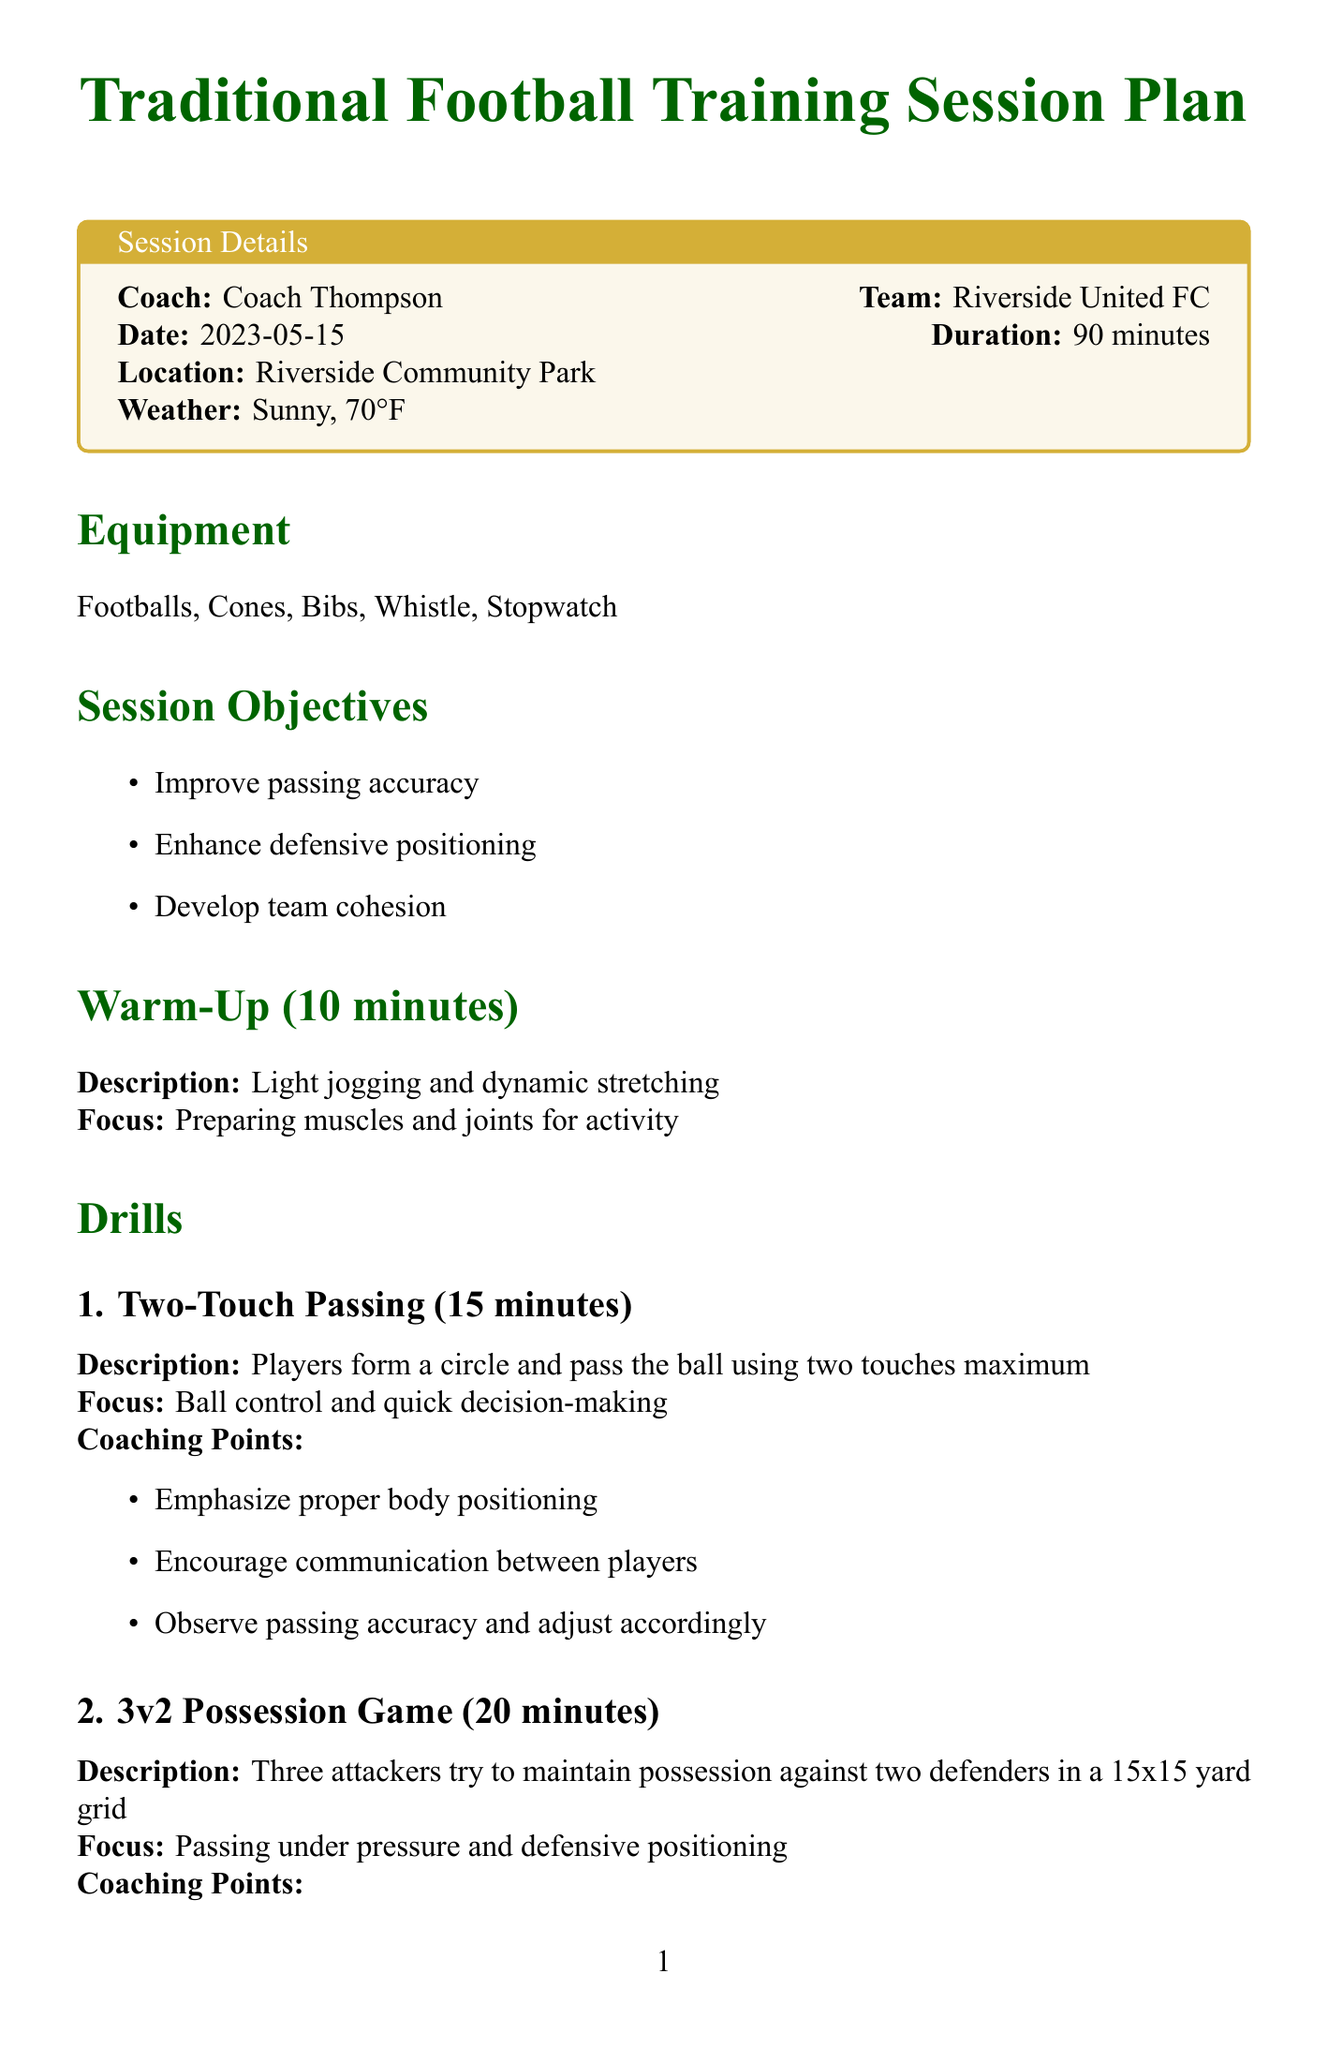what is the coach's name? The coach's name is specified clearly in the document within the session details box.
Answer: Coach Thompson what is the duration of the training session? The duration is listed explicitly in the session details section of the document.
Answer: 90 minutes what is the primary focus during the warm-up? The warm-up section of the document highlights the focus of this activity before the drills begin.
Answer: Preparing muscles and joints for activity how long does the Full-Field Scrimmage last? The duration of the Full-Field Scrimmage drill is provided under the drills section.
Answer: 30 minutes what are the session objectives? The session objectives are specified in a bullet-point list in the document.
Answer: Improve passing accuracy, Enhance defensive positioning, Develop team cohesion which equipment is listed for the training session? The equipment needed for the session is outlined in a separate section and clearly enumerated.
Answer: Footballs, Cones, Bibs, Whistle, Stopwatch what coaching point is emphasized during Two-Touch Passing? This drill includes specific coaching points that highlight what to focus on during the drill.
Answer: Emphasize proper body positioning what is the method of post-session analysis? The document explicitly states the method used for analysis following the session.
Answer: Coach's visual observations how many players are involved in the 3v2 Possession Game? The details of the 3v2 Possession Game specify how many players are on each team.
Answer: Three attackers and two defenders 